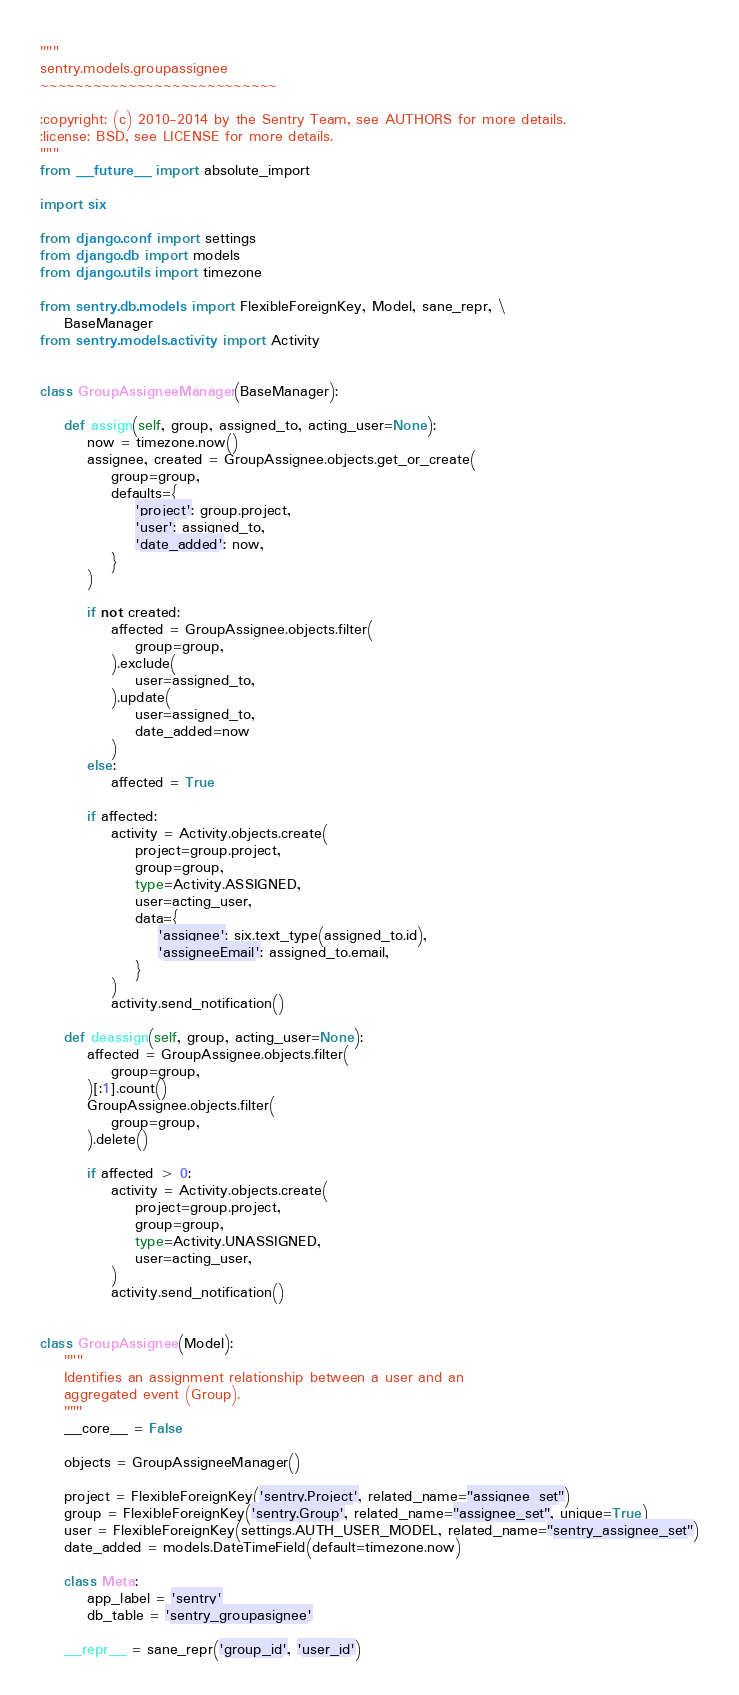Convert code to text. <code><loc_0><loc_0><loc_500><loc_500><_Python_>"""
sentry.models.groupassignee
~~~~~~~~~~~~~~~~~~~~~~~~~~~

:copyright: (c) 2010-2014 by the Sentry Team, see AUTHORS for more details.
:license: BSD, see LICENSE for more details.
"""
from __future__ import absolute_import

import six

from django.conf import settings
from django.db import models
from django.utils import timezone

from sentry.db.models import FlexibleForeignKey, Model, sane_repr, \
    BaseManager
from sentry.models.activity import Activity


class GroupAssigneeManager(BaseManager):

    def assign(self, group, assigned_to, acting_user=None):
        now = timezone.now()
        assignee, created = GroupAssignee.objects.get_or_create(
            group=group,
            defaults={
                'project': group.project,
                'user': assigned_to,
                'date_added': now,
            }
        )

        if not created:
            affected = GroupAssignee.objects.filter(
                group=group,
            ).exclude(
                user=assigned_to,
            ).update(
                user=assigned_to,
                date_added=now
            )
        else:
            affected = True

        if affected:
            activity = Activity.objects.create(
                project=group.project,
                group=group,
                type=Activity.ASSIGNED,
                user=acting_user,
                data={
                    'assignee': six.text_type(assigned_to.id),
                    'assigneeEmail': assigned_to.email,
                }
            )
            activity.send_notification()

    def deassign(self, group, acting_user=None):
        affected = GroupAssignee.objects.filter(
            group=group,
        )[:1].count()
        GroupAssignee.objects.filter(
            group=group,
        ).delete()

        if affected > 0:
            activity = Activity.objects.create(
                project=group.project,
                group=group,
                type=Activity.UNASSIGNED,
                user=acting_user,
            )
            activity.send_notification()


class GroupAssignee(Model):
    """
    Identifies an assignment relationship between a user and an
    aggregated event (Group).
    """
    __core__ = False

    objects = GroupAssigneeManager()

    project = FlexibleForeignKey('sentry.Project', related_name="assignee_set")
    group = FlexibleForeignKey('sentry.Group', related_name="assignee_set", unique=True)
    user = FlexibleForeignKey(settings.AUTH_USER_MODEL, related_name="sentry_assignee_set")
    date_added = models.DateTimeField(default=timezone.now)

    class Meta:
        app_label = 'sentry'
        db_table = 'sentry_groupasignee'

    __repr__ = sane_repr('group_id', 'user_id')
</code> 